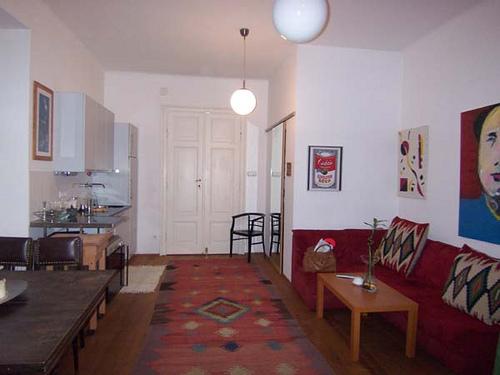Is there any art on the walls?
Short answer required. Yes. What room is this?
Be succinct. Living room. Are both the lights turned on?
Be succinct. No. 